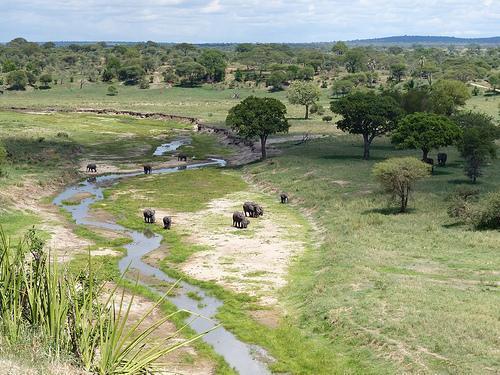How many elephants are pictured?
Give a very brief answer. 9. 